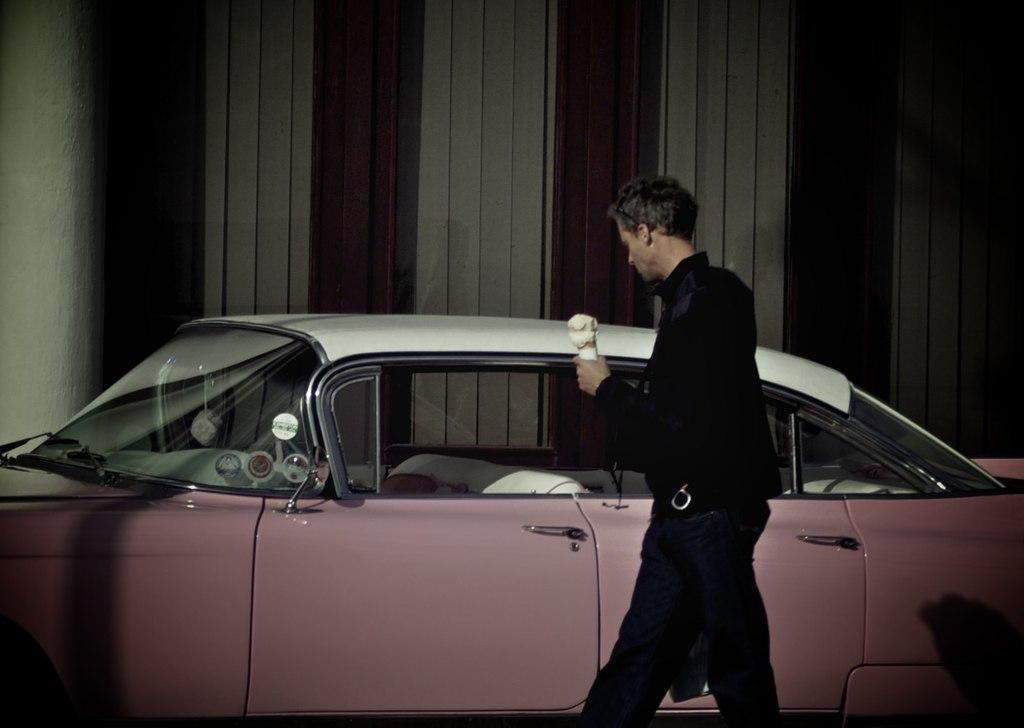What type of motor vehicle is in the image? The specific type of motor vehicle is not mentioned, but there is a motor vehicle in the image. Who is present in the image besides the motor vehicle? A man is standing beside the motor vehicle. What is the man holding in his hand? The man is holding an object in his hand. What can be seen in the background of the image? There is a pillar and a wall in the background of the image. What type of music is the band playing in the background of the image? There is no band present in the image, so it is not possible to determine what type of music might be playing. 